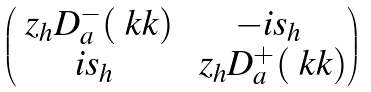<formula> <loc_0><loc_0><loc_500><loc_500>\begin{pmatrix} \ z _ { h } D _ { a } ^ { - } ( \ k k ) & - i s _ { h } \\ i s _ { h } & \ z _ { h } D _ { a } ^ { + } ( \ k k ) \end{pmatrix}</formula> 